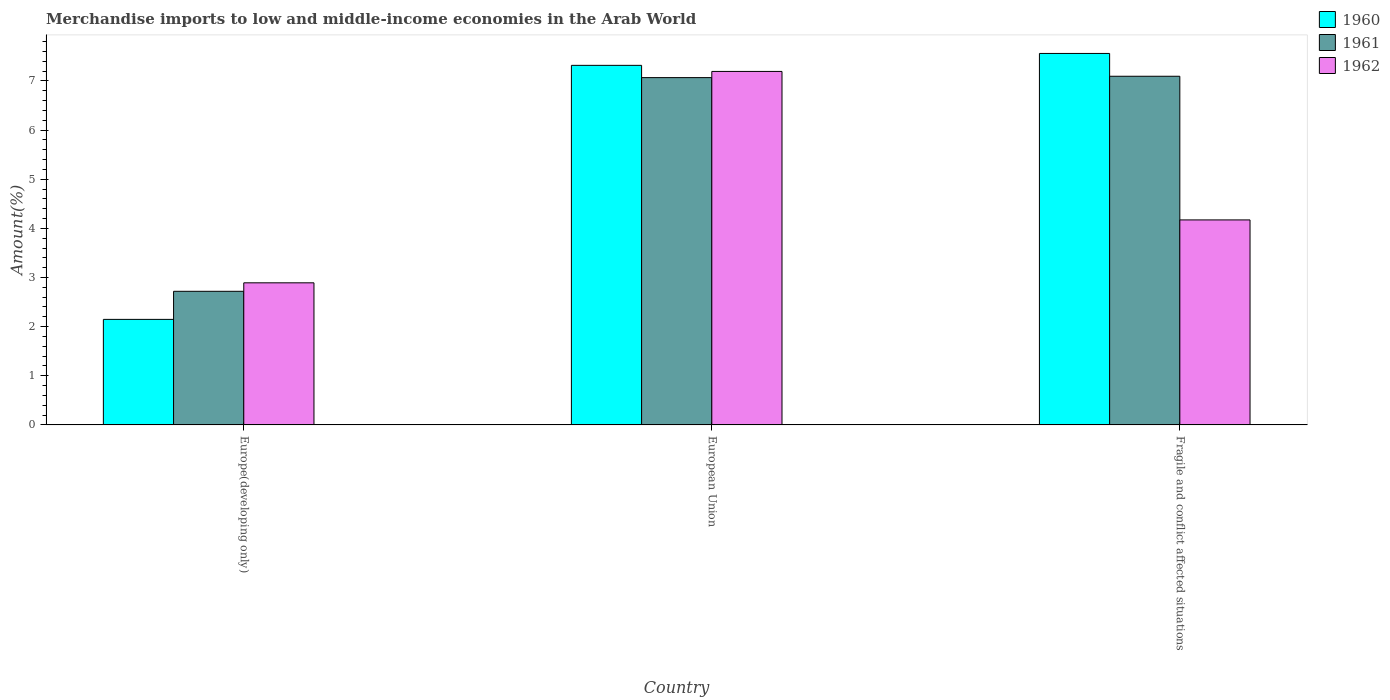How many groups of bars are there?
Make the answer very short. 3. How many bars are there on the 1st tick from the left?
Your response must be concise. 3. What is the label of the 3rd group of bars from the left?
Your answer should be compact. Fragile and conflict affected situations. What is the percentage of amount earned from merchandise imports in 1961 in Fragile and conflict affected situations?
Make the answer very short. 7.1. Across all countries, what is the maximum percentage of amount earned from merchandise imports in 1960?
Provide a succinct answer. 7.56. Across all countries, what is the minimum percentage of amount earned from merchandise imports in 1962?
Keep it short and to the point. 2.89. In which country was the percentage of amount earned from merchandise imports in 1960 maximum?
Give a very brief answer. Fragile and conflict affected situations. In which country was the percentage of amount earned from merchandise imports in 1961 minimum?
Make the answer very short. Europe(developing only). What is the total percentage of amount earned from merchandise imports in 1961 in the graph?
Give a very brief answer. 16.88. What is the difference between the percentage of amount earned from merchandise imports in 1961 in Europe(developing only) and that in European Union?
Offer a very short reply. -4.35. What is the difference between the percentage of amount earned from merchandise imports in 1960 in European Union and the percentage of amount earned from merchandise imports in 1962 in Europe(developing only)?
Provide a short and direct response. 4.43. What is the average percentage of amount earned from merchandise imports in 1960 per country?
Make the answer very short. 5.68. What is the difference between the percentage of amount earned from merchandise imports of/in 1961 and percentage of amount earned from merchandise imports of/in 1962 in Fragile and conflict affected situations?
Keep it short and to the point. 2.92. In how many countries, is the percentage of amount earned from merchandise imports in 1962 greater than 2.2 %?
Provide a short and direct response. 3. What is the ratio of the percentage of amount earned from merchandise imports in 1962 in Europe(developing only) to that in European Union?
Ensure brevity in your answer.  0.4. What is the difference between the highest and the second highest percentage of amount earned from merchandise imports in 1961?
Offer a terse response. -4.35. What is the difference between the highest and the lowest percentage of amount earned from merchandise imports in 1960?
Offer a very short reply. 5.41. In how many countries, is the percentage of amount earned from merchandise imports in 1960 greater than the average percentage of amount earned from merchandise imports in 1960 taken over all countries?
Give a very brief answer. 2. Are all the bars in the graph horizontal?
Your answer should be very brief. No. How many countries are there in the graph?
Make the answer very short. 3. What is the difference between two consecutive major ticks on the Y-axis?
Your response must be concise. 1. Does the graph contain grids?
Your answer should be compact. No. How are the legend labels stacked?
Make the answer very short. Vertical. What is the title of the graph?
Your answer should be compact. Merchandise imports to low and middle-income economies in the Arab World. What is the label or title of the Y-axis?
Your response must be concise. Amount(%). What is the Amount(%) in 1960 in Europe(developing only)?
Offer a terse response. 2.15. What is the Amount(%) in 1961 in Europe(developing only)?
Your answer should be very brief. 2.72. What is the Amount(%) of 1962 in Europe(developing only)?
Your answer should be compact. 2.89. What is the Amount(%) of 1960 in European Union?
Your answer should be very brief. 7.32. What is the Amount(%) in 1961 in European Union?
Your answer should be compact. 7.07. What is the Amount(%) of 1962 in European Union?
Provide a short and direct response. 7.19. What is the Amount(%) in 1960 in Fragile and conflict affected situations?
Your response must be concise. 7.56. What is the Amount(%) of 1961 in Fragile and conflict affected situations?
Make the answer very short. 7.1. What is the Amount(%) in 1962 in Fragile and conflict affected situations?
Your answer should be compact. 4.17. Across all countries, what is the maximum Amount(%) of 1960?
Keep it short and to the point. 7.56. Across all countries, what is the maximum Amount(%) of 1961?
Keep it short and to the point. 7.1. Across all countries, what is the maximum Amount(%) in 1962?
Your answer should be very brief. 7.19. Across all countries, what is the minimum Amount(%) in 1960?
Your answer should be compact. 2.15. Across all countries, what is the minimum Amount(%) in 1961?
Your answer should be very brief. 2.72. Across all countries, what is the minimum Amount(%) in 1962?
Your response must be concise. 2.89. What is the total Amount(%) in 1960 in the graph?
Keep it short and to the point. 17.03. What is the total Amount(%) of 1961 in the graph?
Your response must be concise. 16.88. What is the total Amount(%) in 1962 in the graph?
Offer a terse response. 14.26. What is the difference between the Amount(%) in 1960 in Europe(developing only) and that in European Union?
Ensure brevity in your answer.  -5.17. What is the difference between the Amount(%) in 1961 in Europe(developing only) and that in European Union?
Keep it short and to the point. -4.35. What is the difference between the Amount(%) of 1962 in Europe(developing only) and that in European Union?
Provide a short and direct response. -4.3. What is the difference between the Amount(%) of 1960 in Europe(developing only) and that in Fragile and conflict affected situations?
Your response must be concise. -5.41. What is the difference between the Amount(%) in 1961 in Europe(developing only) and that in Fragile and conflict affected situations?
Provide a short and direct response. -4.38. What is the difference between the Amount(%) of 1962 in Europe(developing only) and that in Fragile and conflict affected situations?
Your answer should be compact. -1.28. What is the difference between the Amount(%) of 1960 in European Union and that in Fragile and conflict affected situations?
Offer a terse response. -0.24. What is the difference between the Amount(%) of 1961 in European Union and that in Fragile and conflict affected situations?
Your answer should be compact. -0.03. What is the difference between the Amount(%) in 1962 in European Union and that in Fragile and conflict affected situations?
Provide a succinct answer. 3.02. What is the difference between the Amount(%) of 1960 in Europe(developing only) and the Amount(%) of 1961 in European Union?
Offer a terse response. -4.92. What is the difference between the Amount(%) of 1960 in Europe(developing only) and the Amount(%) of 1962 in European Union?
Offer a very short reply. -5.05. What is the difference between the Amount(%) of 1961 in Europe(developing only) and the Amount(%) of 1962 in European Union?
Ensure brevity in your answer.  -4.47. What is the difference between the Amount(%) of 1960 in Europe(developing only) and the Amount(%) of 1961 in Fragile and conflict affected situations?
Offer a terse response. -4.95. What is the difference between the Amount(%) of 1960 in Europe(developing only) and the Amount(%) of 1962 in Fragile and conflict affected situations?
Your response must be concise. -2.02. What is the difference between the Amount(%) of 1961 in Europe(developing only) and the Amount(%) of 1962 in Fragile and conflict affected situations?
Your answer should be compact. -1.45. What is the difference between the Amount(%) in 1960 in European Union and the Amount(%) in 1961 in Fragile and conflict affected situations?
Your answer should be very brief. 0.22. What is the difference between the Amount(%) of 1960 in European Union and the Amount(%) of 1962 in Fragile and conflict affected situations?
Offer a very short reply. 3.15. What is the difference between the Amount(%) in 1961 in European Union and the Amount(%) in 1962 in Fragile and conflict affected situations?
Your response must be concise. 2.9. What is the average Amount(%) of 1960 per country?
Keep it short and to the point. 5.68. What is the average Amount(%) in 1961 per country?
Make the answer very short. 5.63. What is the average Amount(%) of 1962 per country?
Keep it short and to the point. 4.75. What is the difference between the Amount(%) in 1960 and Amount(%) in 1961 in Europe(developing only)?
Make the answer very short. -0.57. What is the difference between the Amount(%) in 1960 and Amount(%) in 1962 in Europe(developing only)?
Make the answer very short. -0.74. What is the difference between the Amount(%) in 1961 and Amount(%) in 1962 in Europe(developing only)?
Make the answer very short. -0.17. What is the difference between the Amount(%) in 1960 and Amount(%) in 1961 in European Union?
Your response must be concise. 0.25. What is the difference between the Amount(%) of 1960 and Amount(%) of 1962 in European Union?
Give a very brief answer. 0.12. What is the difference between the Amount(%) of 1961 and Amount(%) of 1962 in European Union?
Provide a succinct answer. -0.13. What is the difference between the Amount(%) of 1960 and Amount(%) of 1961 in Fragile and conflict affected situations?
Give a very brief answer. 0.46. What is the difference between the Amount(%) of 1960 and Amount(%) of 1962 in Fragile and conflict affected situations?
Offer a terse response. 3.39. What is the difference between the Amount(%) in 1961 and Amount(%) in 1962 in Fragile and conflict affected situations?
Provide a short and direct response. 2.92. What is the ratio of the Amount(%) in 1960 in Europe(developing only) to that in European Union?
Give a very brief answer. 0.29. What is the ratio of the Amount(%) of 1961 in Europe(developing only) to that in European Union?
Provide a succinct answer. 0.38. What is the ratio of the Amount(%) of 1962 in Europe(developing only) to that in European Union?
Ensure brevity in your answer.  0.4. What is the ratio of the Amount(%) in 1960 in Europe(developing only) to that in Fragile and conflict affected situations?
Give a very brief answer. 0.28. What is the ratio of the Amount(%) of 1961 in Europe(developing only) to that in Fragile and conflict affected situations?
Your response must be concise. 0.38. What is the ratio of the Amount(%) in 1962 in Europe(developing only) to that in Fragile and conflict affected situations?
Provide a short and direct response. 0.69. What is the ratio of the Amount(%) of 1962 in European Union to that in Fragile and conflict affected situations?
Keep it short and to the point. 1.72. What is the difference between the highest and the second highest Amount(%) of 1960?
Provide a succinct answer. 0.24. What is the difference between the highest and the second highest Amount(%) in 1961?
Make the answer very short. 0.03. What is the difference between the highest and the second highest Amount(%) of 1962?
Offer a terse response. 3.02. What is the difference between the highest and the lowest Amount(%) in 1960?
Your response must be concise. 5.41. What is the difference between the highest and the lowest Amount(%) of 1961?
Offer a terse response. 4.38. What is the difference between the highest and the lowest Amount(%) in 1962?
Your answer should be very brief. 4.3. 